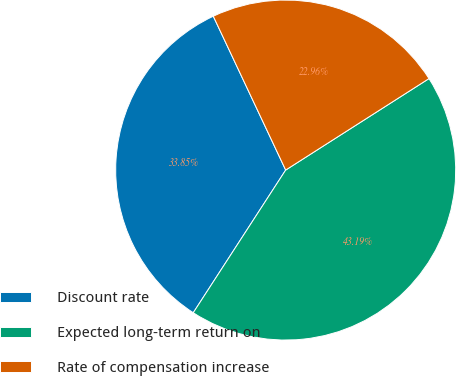Convert chart. <chart><loc_0><loc_0><loc_500><loc_500><pie_chart><fcel>Discount rate<fcel>Expected long-term return on<fcel>Rate of compensation increase<nl><fcel>33.85%<fcel>43.19%<fcel>22.96%<nl></chart> 